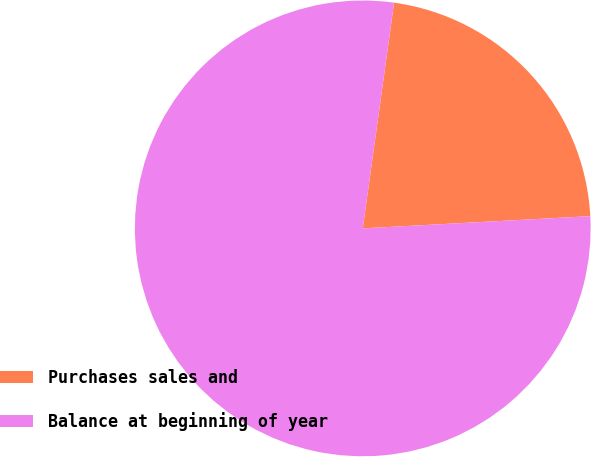<chart> <loc_0><loc_0><loc_500><loc_500><pie_chart><fcel>Purchases sales and<fcel>Balance at beginning of year<nl><fcel>21.95%<fcel>78.05%<nl></chart> 